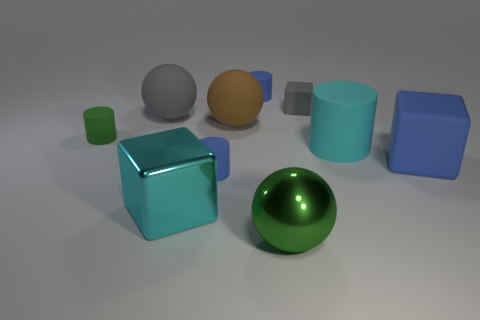Are there fewer small things right of the brown matte thing than green spheres?
Ensure brevity in your answer.  No. What is the shape of the large gray object that is made of the same material as the big brown thing?
Provide a succinct answer. Sphere. There is a cyan object that is behind the big blue matte block; does it have the same shape as the large brown thing on the right side of the small green thing?
Provide a short and direct response. No. Are there fewer large matte cylinders that are in front of the large green object than tiny rubber cubes that are in front of the brown thing?
Offer a terse response. No. There is a big matte object that is the same color as the small cube; what shape is it?
Offer a terse response. Sphere. What number of other gray balls are the same size as the metallic sphere?
Your answer should be very brief. 1. Are the green thing in front of the green rubber cylinder and the big gray sphere made of the same material?
Keep it short and to the point. No. Is there a green metallic ball?
Provide a short and direct response. Yes. What is the size of the gray thing that is made of the same material as the large gray sphere?
Ensure brevity in your answer.  Small. Are there any small cylinders that have the same color as the shiny sphere?
Your answer should be compact. Yes. 